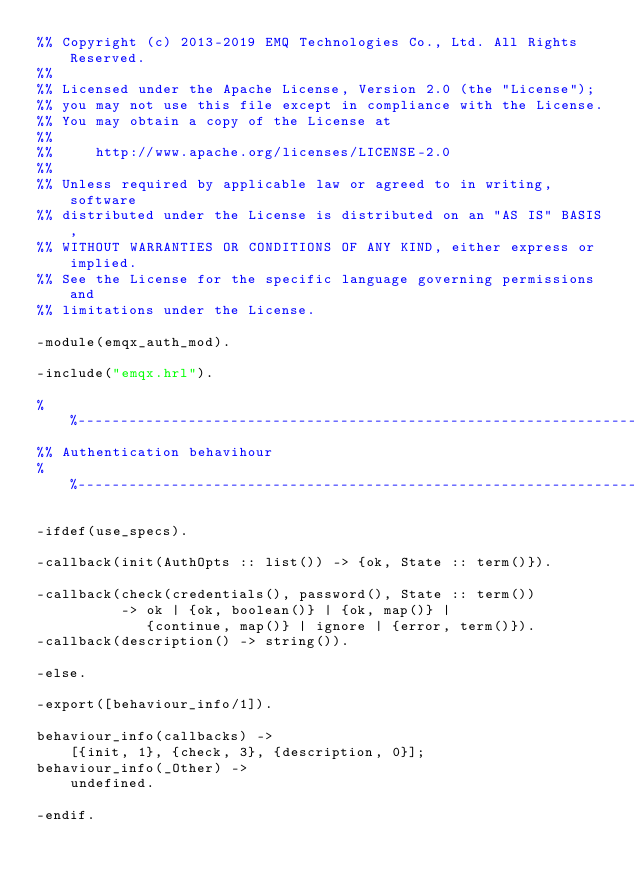Convert code to text. <code><loc_0><loc_0><loc_500><loc_500><_Erlang_>%% Copyright (c) 2013-2019 EMQ Technologies Co., Ltd. All Rights Reserved.
%%
%% Licensed under the Apache License, Version 2.0 (the "License");
%% you may not use this file except in compliance with the License.
%% You may obtain a copy of the License at
%%
%%     http://www.apache.org/licenses/LICENSE-2.0
%%
%% Unless required by applicable law or agreed to in writing, software
%% distributed under the License is distributed on an "AS IS" BASIS,
%% WITHOUT WARRANTIES OR CONDITIONS OF ANY KIND, either express or implied.
%% See the License for the specific language governing permissions and
%% limitations under the License.

-module(emqx_auth_mod).

-include("emqx.hrl").

%%--------------------------------------------------------------------
%% Authentication behavihour
%%--------------------------------------------------------------------

-ifdef(use_specs).

-callback(init(AuthOpts :: list()) -> {ok, State :: term()}).

-callback(check(credentials(), password(), State :: term())
          -> ok | {ok, boolean()} | {ok, map()} |
             {continue, map()} | ignore | {error, term()}).
-callback(description() -> string()).

-else.

-export([behaviour_info/1]).

behaviour_info(callbacks) ->
    [{init, 1}, {check, 3}, {description, 0}];
behaviour_info(_Other) ->
    undefined.

-endif.
</code> 